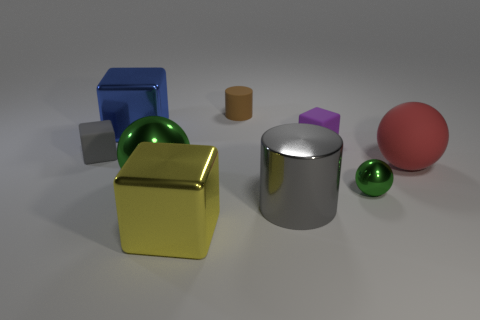The large object that is on the left side of the green metallic thing to the left of the big metallic cube in front of the blue shiny block is what shape? cube 